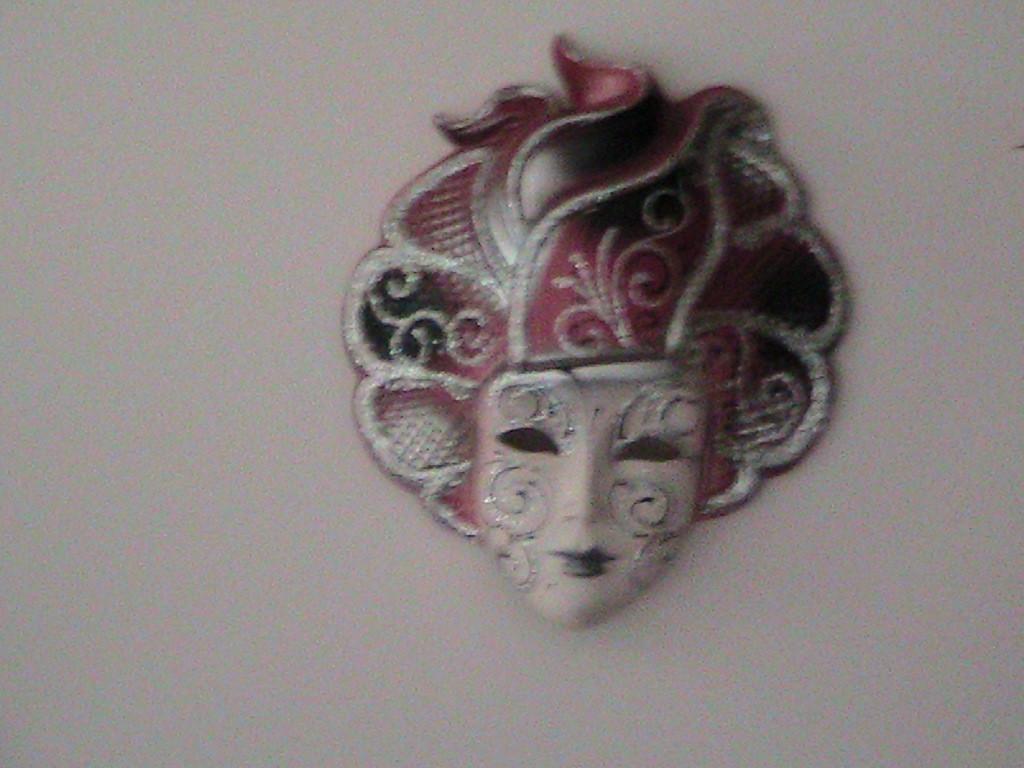Could you give a brief overview of what you see in this image? In the picture we can see the human face sculpture to the wall. 